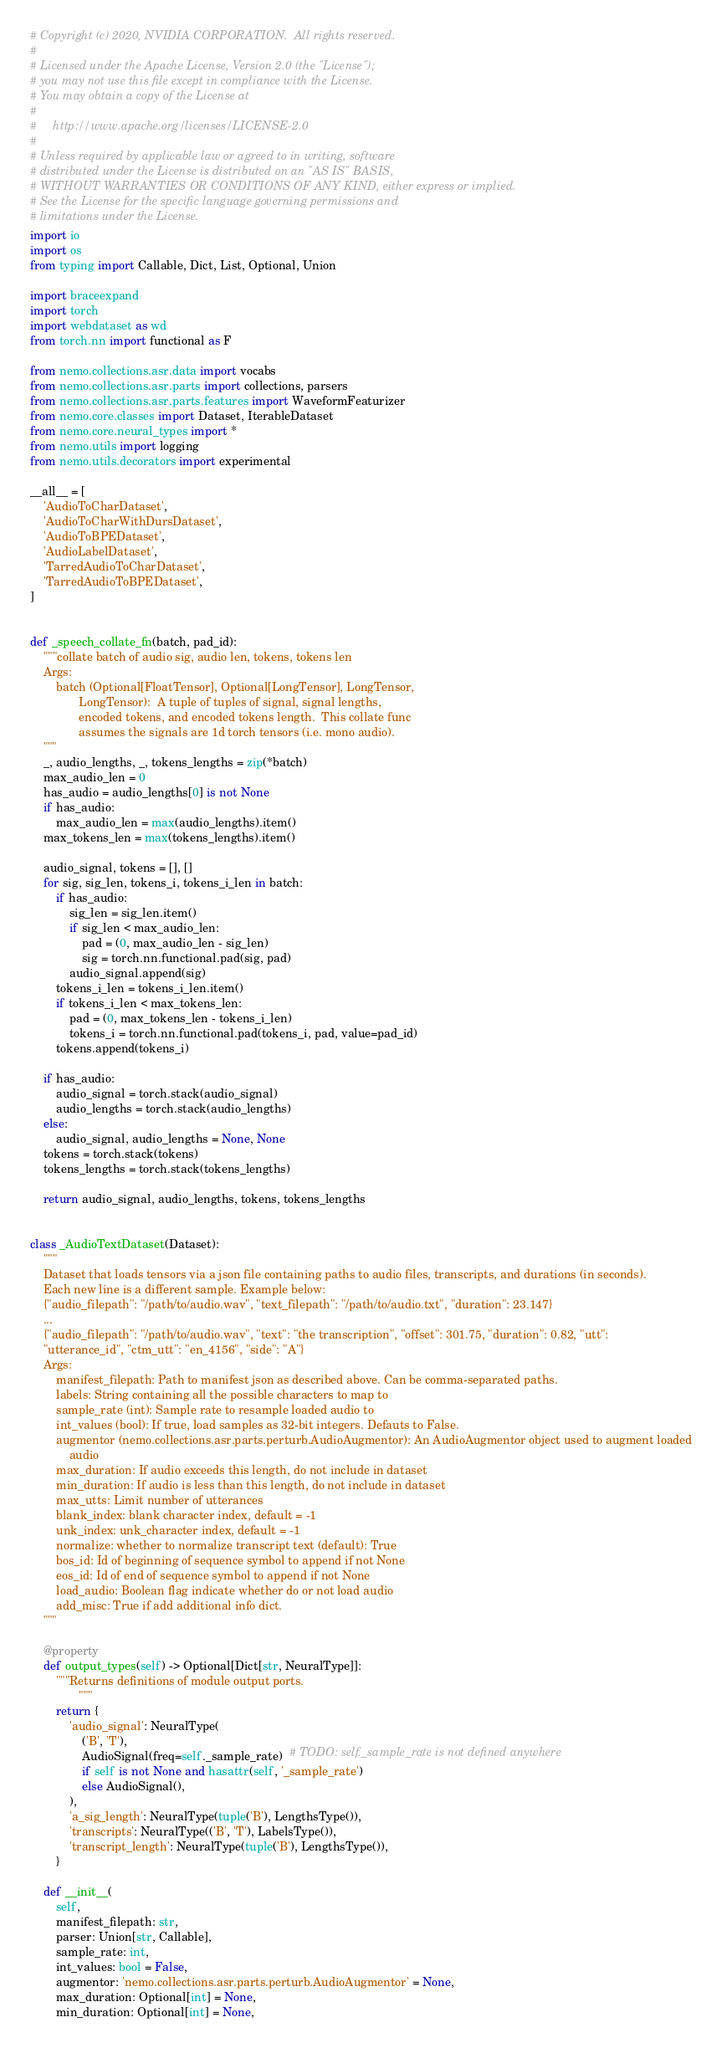Convert code to text. <code><loc_0><loc_0><loc_500><loc_500><_Python_># Copyright (c) 2020, NVIDIA CORPORATION.  All rights reserved.
#
# Licensed under the Apache License, Version 2.0 (the "License");
# you may not use this file except in compliance with the License.
# You may obtain a copy of the License at
#
#     http://www.apache.org/licenses/LICENSE-2.0
#
# Unless required by applicable law or agreed to in writing, software
# distributed under the License is distributed on an "AS IS" BASIS,
# WITHOUT WARRANTIES OR CONDITIONS OF ANY KIND, either express or implied.
# See the License for the specific language governing permissions and
# limitations under the License.
import io
import os
from typing import Callable, Dict, List, Optional, Union

import braceexpand
import torch
import webdataset as wd
from torch.nn import functional as F

from nemo.collections.asr.data import vocabs
from nemo.collections.asr.parts import collections, parsers
from nemo.collections.asr.parts.features import WaveformFeaturizer
from nemo.core.classes import Dataset, IterableDataset
from nemo.core.neural_types import *
from nemo.utils import logging
from nemo.utils.decorators import experimental

__all__ = [
    'AudioToCharDataset',
    'AudioToCharWithDursDataset',
    'AudioToBPEDataset',
    'AudioLabelDataset',
    'TarredAudioToCharDataset',
    'TarredAudioToBPEDataset',
]


def _speech_collate_fn(batch, pad_id):
    """collate batch of audio sig, audio len, tokens, tokens len
    Args:
        batch (Optional[FloatTensor], Optional[LongTensor], LongTensor,
               LongTensor):  A tuple of tuples of signal, signal lengths,
               encoded tokens, and encoded tokens length.  This collate func
               assumes the signals are 1d torch tensors (i.e. mono audio).
    """
    _, audio_lengths, _, tokens_lengths = zip(*batch)
    max_audio_len = 0
    has_audio = audio_lengths[0] is not None
    if has_audio:
        max_audio_len = max(audio_lengths).item()
    max_tokens_len = max(tokens_lengths).item()

    audio_signal, tokens = [], []
    for sig, sig_len, tokens_i, tokens_i_len in batch:
        if has_audio:
            sig_len = sig_len.item()
            if sig_len < max_audio_len:
                pad = (0, max_audio_len - sig_len)
                sig = torch.nn.functional.pad(sig, pad)
            audio_signal.append(sig)
        tokens_i_len = tokens_i_len.item()
        if tokens_i_len < max_tokens_len:
            pad = (0, max_tokens_len - tokens_i_len)
            tokens_i = torch.nn.functional.pad(tokens_i, pad, value=pad_id)
        tokens.append(tokens_i)

    if has_audio:
        audio_signal = torch.stack(audio_signal)
        audio_lengths = torch.stack(audio_lengths)
    else:
        audio_signal, audio_lengths = None, None
    tokens = torch.stack(tokens)
    tokens_lengths = torch.stack(tokens_lengths)

    return audio_signal, audio_lengths, tokens, tokens_lengths


class _AudioTextDataset(Dataset):
    """
    Dataset that loads tensors via a json file containing paths to audio files, transcripts, and durations (in seconds).
    Each new line is a different sample. Example below:
    {"audio_filepath": "/path/to/audio.wav", "text_filepath": "/path/to/audio.txt", "duration": 23.147}
    ...
    {"audio_filepath": "/path/to/audio.wav", "text": "the transcription", "offset": 301.75, "duration": 0.82, "utt":
    "utterance_id", "ctm_utt": "en_4156", "side": "A"}
    Args:
        manifest_filepath: Path to manifest json as described above. Can be comma-separated paths.
        labels: String containing all the possible characters to map to
        sample_rate (int): Sample rate to resample loaded audio to
        int_values (bool): If true, load samples as 32-bit integers. Defauts to False.
        augmentor (nemo.collections.asr.parts.perturb.AudioAugmentor): An AudioAugmentor object used to augment loaded
            audio
        max_duration: If audio exceeds this length, do not include in dataset
        min_duration: If audio is less than this length, do not include in dataset
        max_utts: Limit number of utterances
        blank_index: blank character index, default = -1
        unk_index: unk_character index, default = -1
        normalize: whether to normalize transcript text (default): True
        bos_id: Id of beginning of sequence symbol to append if not None
        eos_id: Id of end of sequence symbol to append if not None
        load_audio: Boolean flag indicate whether do or not load audio
        add_misc: True if add additional info dict.
    """

    @property
    def output_types(self) -> Optional[Dict[str, NeuralType]]:
        """Returns definitions of module output ports.
               """
        return {
            'audio_signal': NeuralType(
                ('B', 'T'),
                AudioSignal(freq=self._sample_rate)  # TODO: self._sample_rate is not defined anywhere
                if self is not None and hasattr(self, '_sample_rate')
                else AudioSignal(),
            ),
            'a_sig_length': NeuralType(tuple('B'), LengthsType()),
            'transcripts': NeuralType(('B', 'T'), LabelsType()),
            'transcript_length': NeuralType(tuple('B'), LengthsType()),
        }

    def __init__(
        self,
        manifest_filepath: str,
        parser: Union[str, Callable],
        sample_rate: int,
        int_values: bool = False,
        augmentor: 'nemo.collections.asr.parts.perturb.AudioAugmentor' = None,
        max_duration: Optional[int] = None,
        min_duration: Optional[int] = None,</code> 